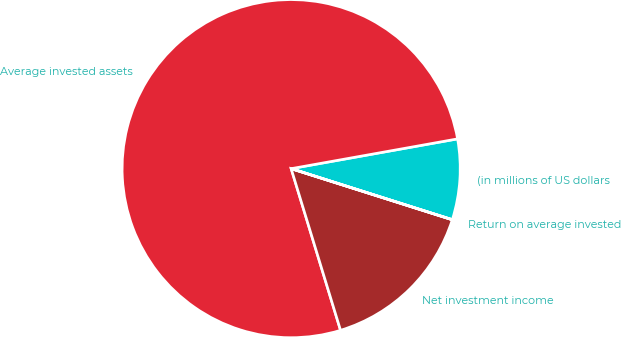Convert chart. <chart><loc_0><loc_0><loc_500><loc_500><pie_chart><fcel>(in millions of US dollars<fcel>Average invested assets<fcel>Net investment income<fcel>Return on average invested<nl><fcel>7.7%<fcel>76.9%<fcel>15.39%<fcel>0.01%<nl></chart> 